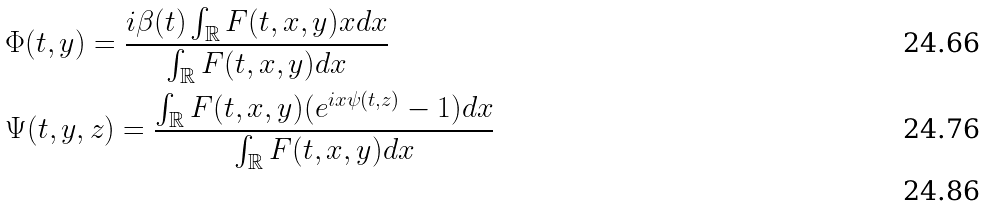Convert formula to latex. <formula><loc_0><loc_0><loc_500><loc_500>& \Phi ( t , y ) = \frac { i \beta ( t ) \int _ { \mathbb { R } } F ( t , x , y ) x d x } { \int _ { \mathbb { R } } F ( t , x , y ) d x } \\ & \Psi ( t , y , z ) = \frac { \int _ { \mathbb { R } } F ( t , x , y ) ( e ^ { i x \psi ( t , z ) } - 1 ) d x } { \int _ { \mathbb { R } } F ( t , x , y ) d x } \\</formula> 